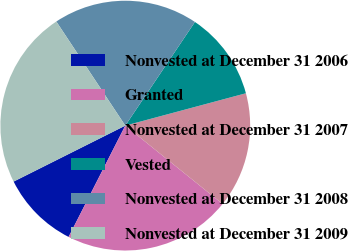<chart> <loc_0><loc_0><loc_500><loc_500><pie_chart><fcel>Nonvested at December 31 2006<fcel>Granted<fcel>Nonvested at December 31 2007<fcel>Vested<fcel>Nonvested at December 31 2008<fcel>Nonvested at December 31 2009<nl><fcel>10.11%<fcel>21.71%<fcel>14.96%<fcel>11.41%<fcel>18.73%<fcel>23.08%<nl></chart> 